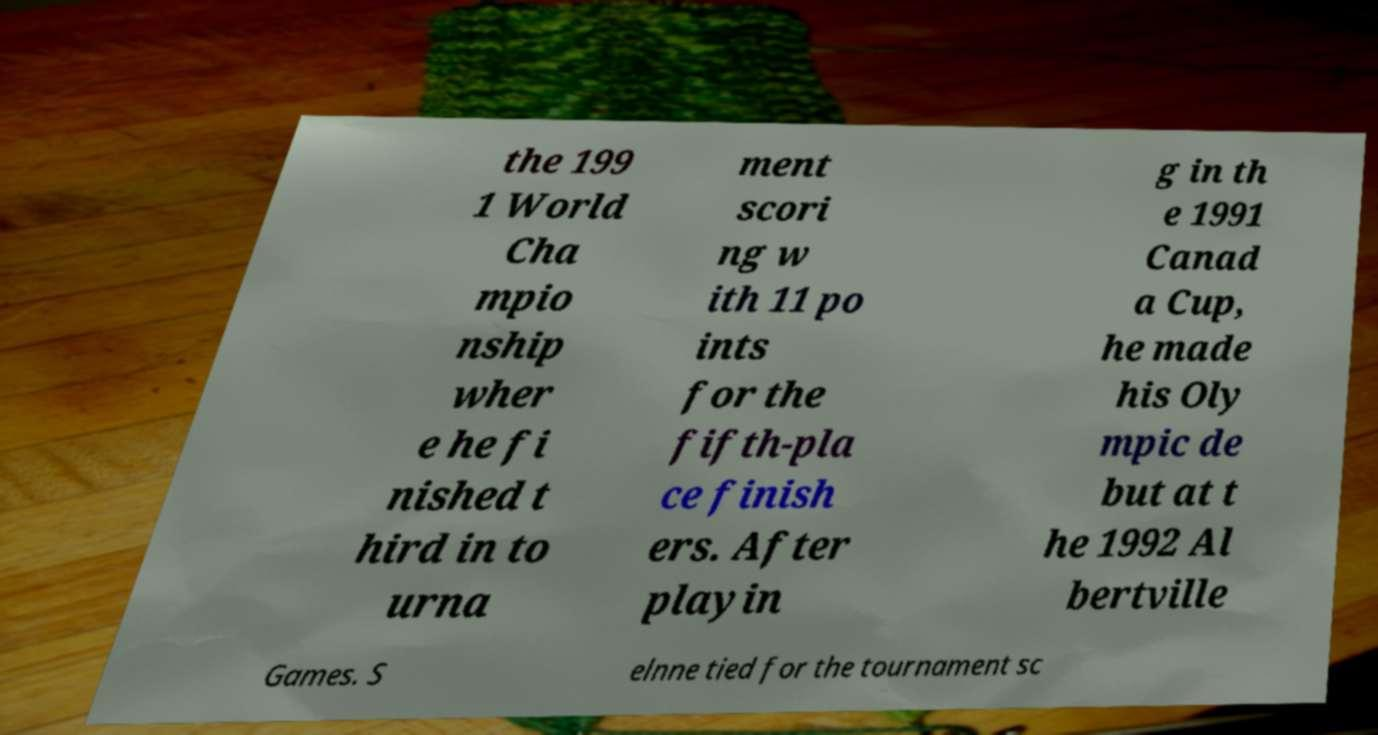Can you accurately transcribe the text from the provided image for me? the 199 1 World Cha mpio nship wher e he fi nished t hird in to urna ment scori ng w ith 11 po ints for the fifth-pla ce finish ers. After playin g in th e 1991 Canad a Cup, he made his Oly mpic de but at t he 1992 Al bertville Games. S elnne tied for the tournament sc 